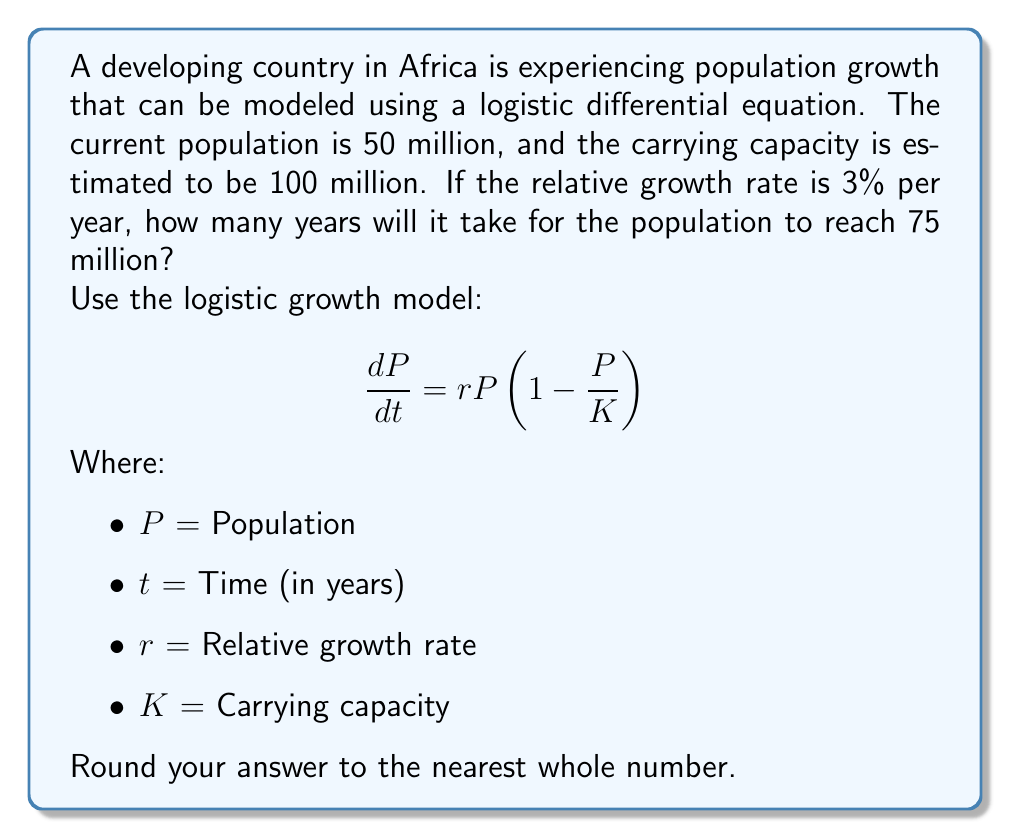Give your solution to this math problem. Let's approach this step-by-step:

1) First, we need to solve the logistic differential equation. The solution to this equation is:

   $$P(t) = \frac{K}{1 + (\frac{K}{P_0} - 1)e^{-rt}}$$

   Where $P_0$ is the initial population.

2) We're given:
   $P_0 = 50$ million
   $K = 100$ million
   $r = 0.03$ (3% per year)

3) We want to find $t$ when $P(t) = 75$ million. Let's substitute these values into the equation:

   $$75 = \frac{100}{1 + (\frac{100}{50} - 1)e^{-0.03t}}$$

4) Simplify:
   $$75 = \frac{100}{1 + e^{-0.03t}}$$

5) Multiply both sides by $(1 + e^{-0.03t})$:
   $$75(1 + e^{-0.03t}) = 100$$

6) Expand:
   $$75 + 75e^{-0.03t} = 100$$

7) Subtract 75 from both sides:
   $$75e^{-0.03t} = 25$$

8) Divide both sides by 75:
   $$e^{-0.03t} = \frac{1}{3}$$

9) Take the natural log of both sides:
   $$-0.03t = \ln(\frac{1}{3})$$

10) Divide both sides by -0.03:
    $$t = \frac{\ln(\frac{1}{3})}{-0.03} \approx 36.73$$

11) Rounding to the nearest whole number:
    $t \approx 37$ years
Answer: 37 years 